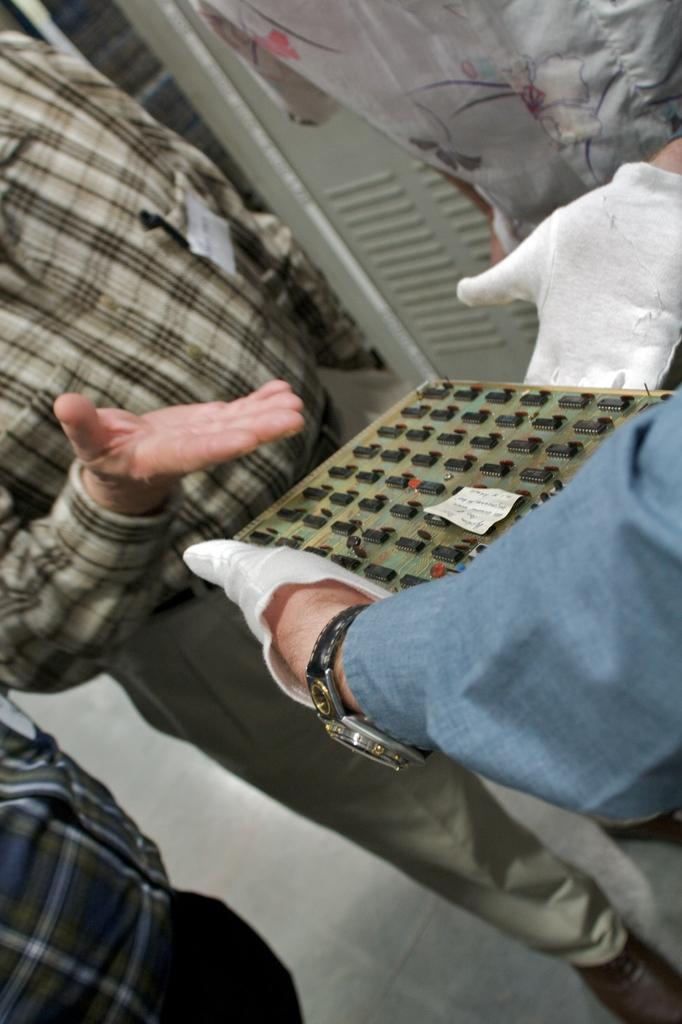Who is the main subject on the right side of the image? There is a person on the right side of the image. What is the person holding in the image? The person is holding an electric board. Are there any other people present in the image? Yes, there are people standing around the person. What can be seen in the background of the image? There appears to be a cupboard in the background of the image. Can you tell me how many geese are in the hospital in the image? There are no geese or hospitals present in the image. What type of star is visible in the image? There is no star visible in the image. 